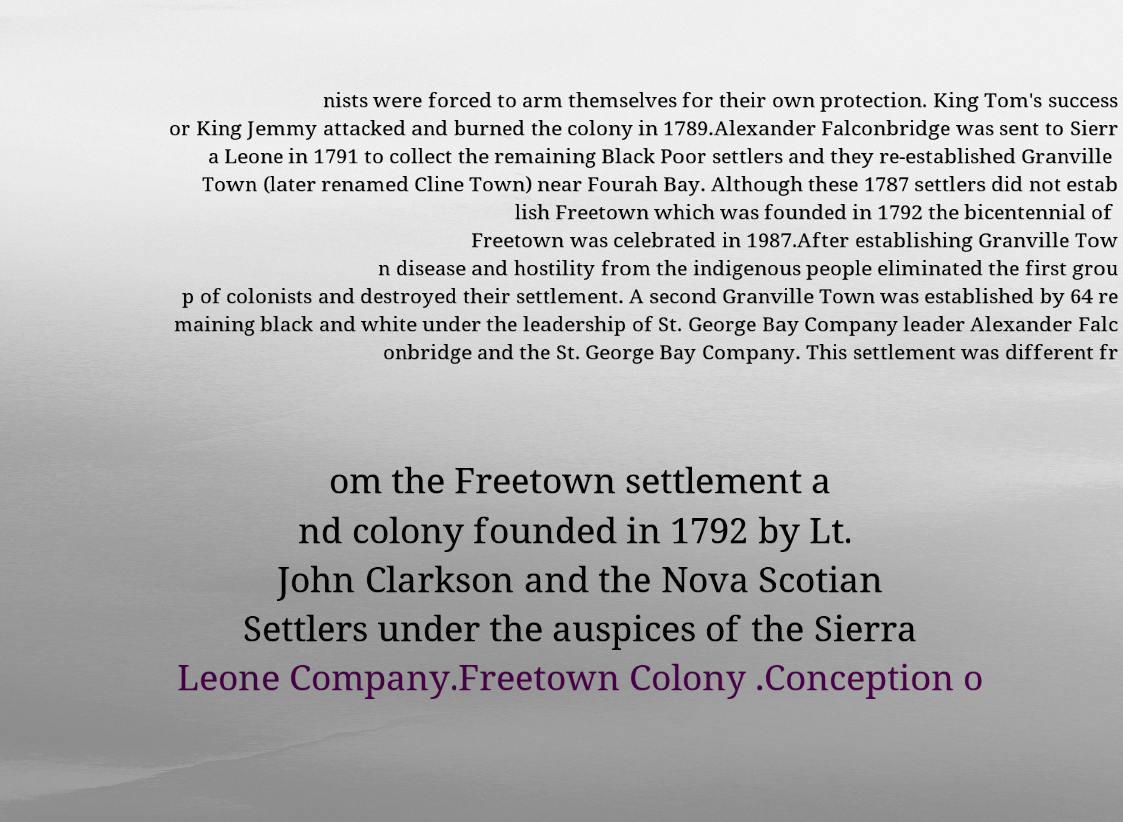Please identify and transcribe the text found in this image. nists were forced to arm themselves for their own protection. King Tom's success or King Jemmy attacked and burned the colony in 1789.Alexander Falconbridge was sent to Sierr a Leone in 1791 to collect the remaining Black Poor settlers and they re-established Granville Town (later renamed Cline Town) near Fourah Bay. Although these 1787 settlers did not estab lish Freetown which was founded in 1792 the bicentennial of Freetown was celebrated in 1987.After establishing Granville Tow n disease and hostility from the indigenous people eliminated the first grou p of colonists and destroyed their settlement. A second Granville Town was established by 64 re maining black and white under the leadership of St. George Bay Company leader Alexander Falc onbridge and the St. George Bay Company. This settlement was different fr om the Freetown settlement a nd colony founded in 1792 by Lt. John Clarkson and the Nova Scotian Settlers under the auspices of the Sierra Leone Company.Freetown Colony .Conception o 